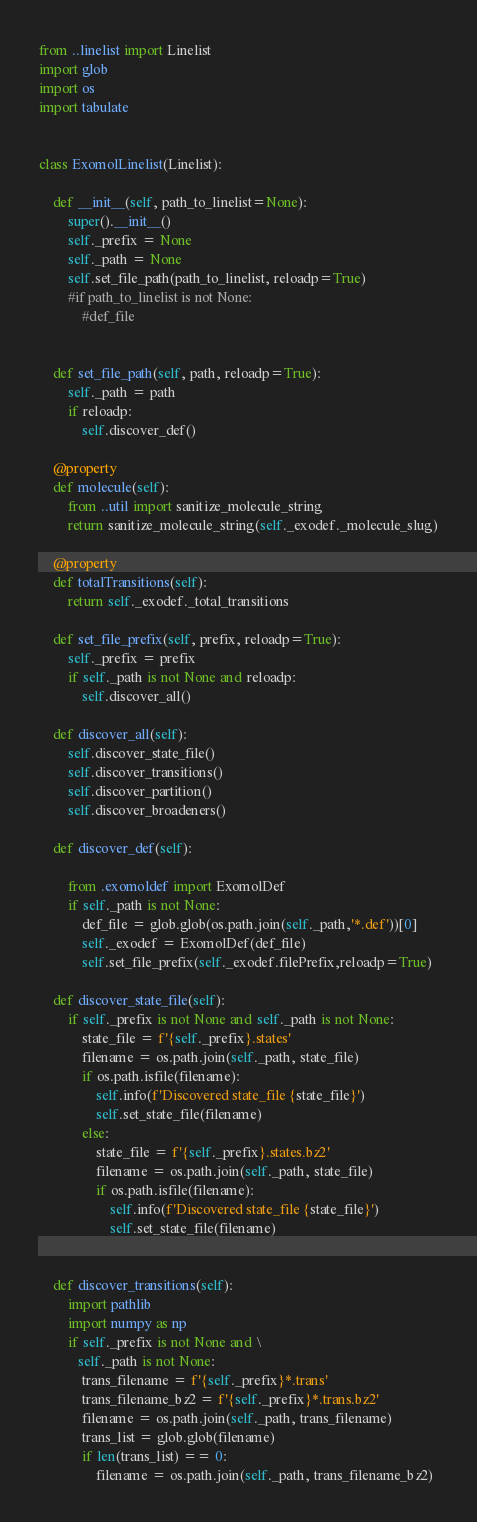<code> <loc_0><loc_0><loc_500><loc_500><_Python_>from ..linelist import Linelist
import glob
import os
import tabulate


class ExomolLinelist(Linelist):

    def __init__(self, path_to_linelist=None):
        super().__init__()
        self._prefix = None
        self._path = None
        self.set_file_path(path_to_linelist, reloadp=True)
        #if path_to_linelist is not None:
            #def_file


    def set_file_path(self, path, reloadp=True):
        self._path = path
        if reloadp:
            self.discover_def()

    @property
    def molecule(self):
        from ..util import sanitize_molecule_string
        return sanitize_molecule_string(self._exodef._molecule_slug)

    @property
    def totalTransitions(self):
        return self._exodef._total_transitions

    def set_file_prefix(self, prefix, reloadp=True):
        self._prefix = prefix
        if self._path is not None and reloadp:
            self.discover_all()
    
    def discover_all(self):
        self.discover_state_file()
        self.discover_transitions()
        self.discover_partition()
        self.discover_broadeners()

    def discover_def(self):
        
        from .exomoldef import ExomolDef
        if self._path is not None:
            def_file = glob.glob(os.path.join(self._path,'*.def'))[0]
            self._exodef = ExomolDef(def_file)
            self.set_file_prefix(self._exodef.filePrefix,reloadp=True)

    def discover_state_file(self):
        if self._prefix is not None and self._path is not None:
            state_file = f'{self._prefix}.states'
            filename = os.path.join(self._path, state_file)
            if os.path.isfile(filename):
                self.info(f'Discovered state_file {state_file}')
                self.set_state_file(filename)
            else:
                state_file = f'{self._prefix}.states.bz2'
                filename = os.path.join(self._path, state_file)
                if os.path.isfile(filename):
                    self.info(f'Discovered state_file {state_file}')
                    self.set_state_file(filename)


    def discover_transitions(self):
        import pathlib
        import numpy as np
        if self._prefix is not None and \
           self._path is not None:
            trans_filename = f'{self._prefix}*.trans'
            trans_filename_bz2 = f'{self._prefix}*.trans.bz2'
            filename = os.path.join(self._path, trans_filename)
            trans_list = glob.glob(filename)
            if len(trans_list) == 0:
                filename = os.path.join(self._path, trans_filename_bz2)</code> 